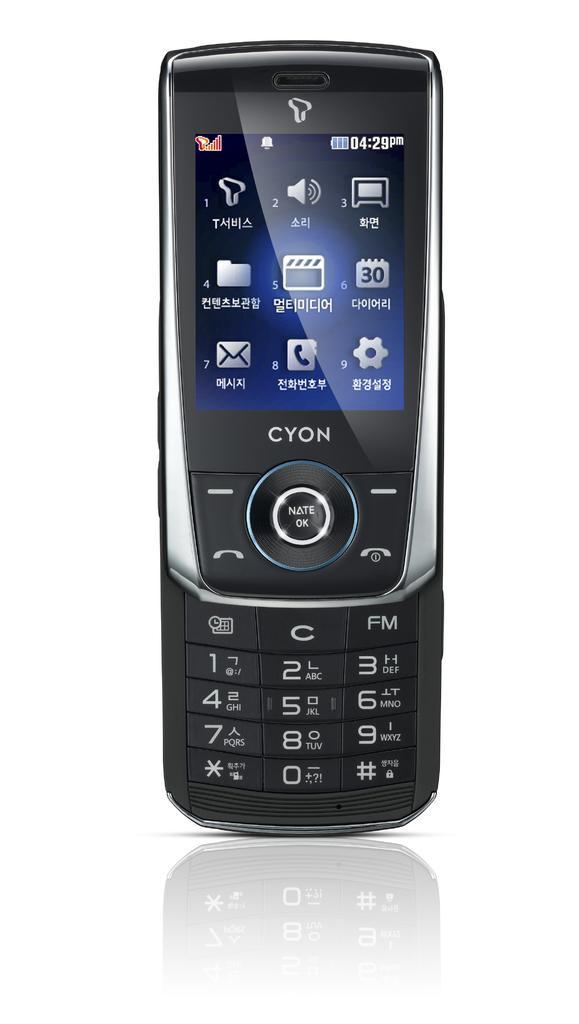Describe this image in one or two sentences. In the center of the image a mobile is there. 